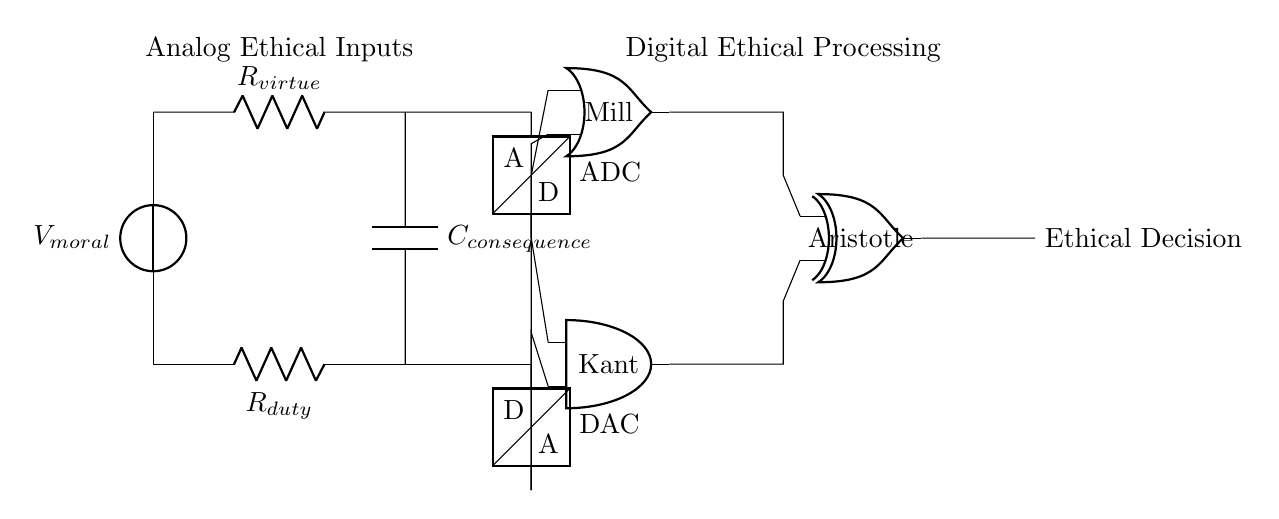What is the voltage source in this circuit? The voltage source in the circuit is labeled as V moral, providing the potential difference needed for the analog section.
Answer: V moral What is the function of the resistor labeled R virtue? The resistor labeled R virtue is part of the analog section and corresponds to the virtue ethics component, influencing the current flow in relation to moral values.
Answer: Virtue ethics Which digital component represents Kant's ethical theory? The digital component that represents Kant's ethical theory is the AND gate located on the left side of the digital section of the circuit.
Answer: AND gate What type of output does the circuit provide? The output of the circuit is obtained from the XOR gate, indicating the final ethical decision based on the processed inputs from both analog and digital sections.
Answer: Ethical Decision How many components are in the analog section? The analog section consists of four components: a voltage source, two resistors, and a capacitor.
Answer: Four What role does the ADC play in the circuit? The ADC (Analog to Digital Converter) in the circuit transforms the analog signals into a digital form for processing by the digital components, bridging the analog and digital parts.
Answer: Digital conversion Which ethical theory is represented by the OR gate? The ethical theory represented by the OR gate is utilitarianism, associated with Mill’s philosophy and positioned near the top of the digital section.
Answer: Utilitarianism 